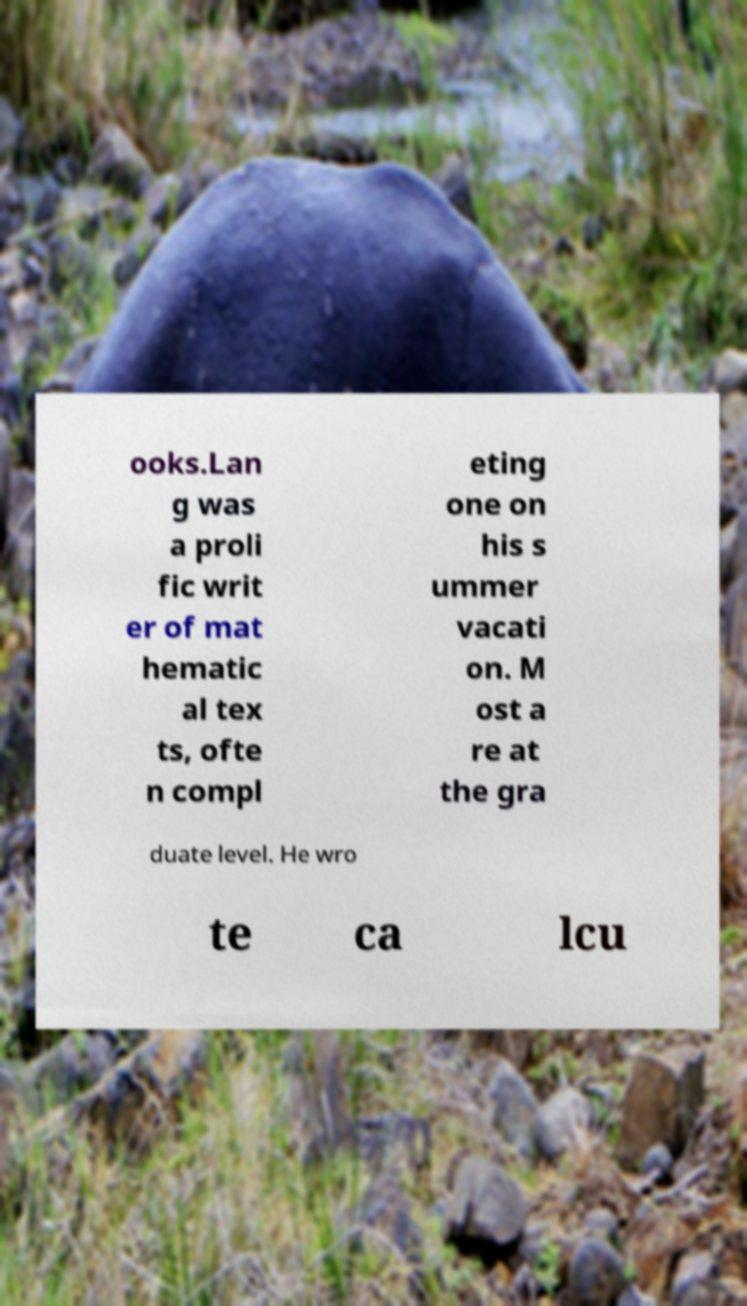I need the written content from this picture converted into text. Can you do that? ooks.Lan g was a proli fic writ er of mat hematic al tex ts, ofte n compl eting one on his s ummer vacati on. M ost a re at the gra duate level. He wro te ca lcu 